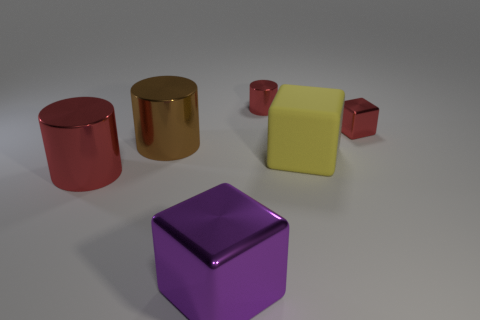Subtract all purple cubes. Subtract all blue cylinders. How many cubes are left? 2 Add 3 big yellow metallic objects. How many objects exist? 9 Subtract all metallic cubes. Subtract all large purple things. How many objects are left? 3 Add 6 tiny red cubes. How many tiny red cubes are left? 7 Add 1 big brown cylinders. How many big brown cylinders exist? 2 Subtract 0 gray cylinders. How many objects are left? 6 